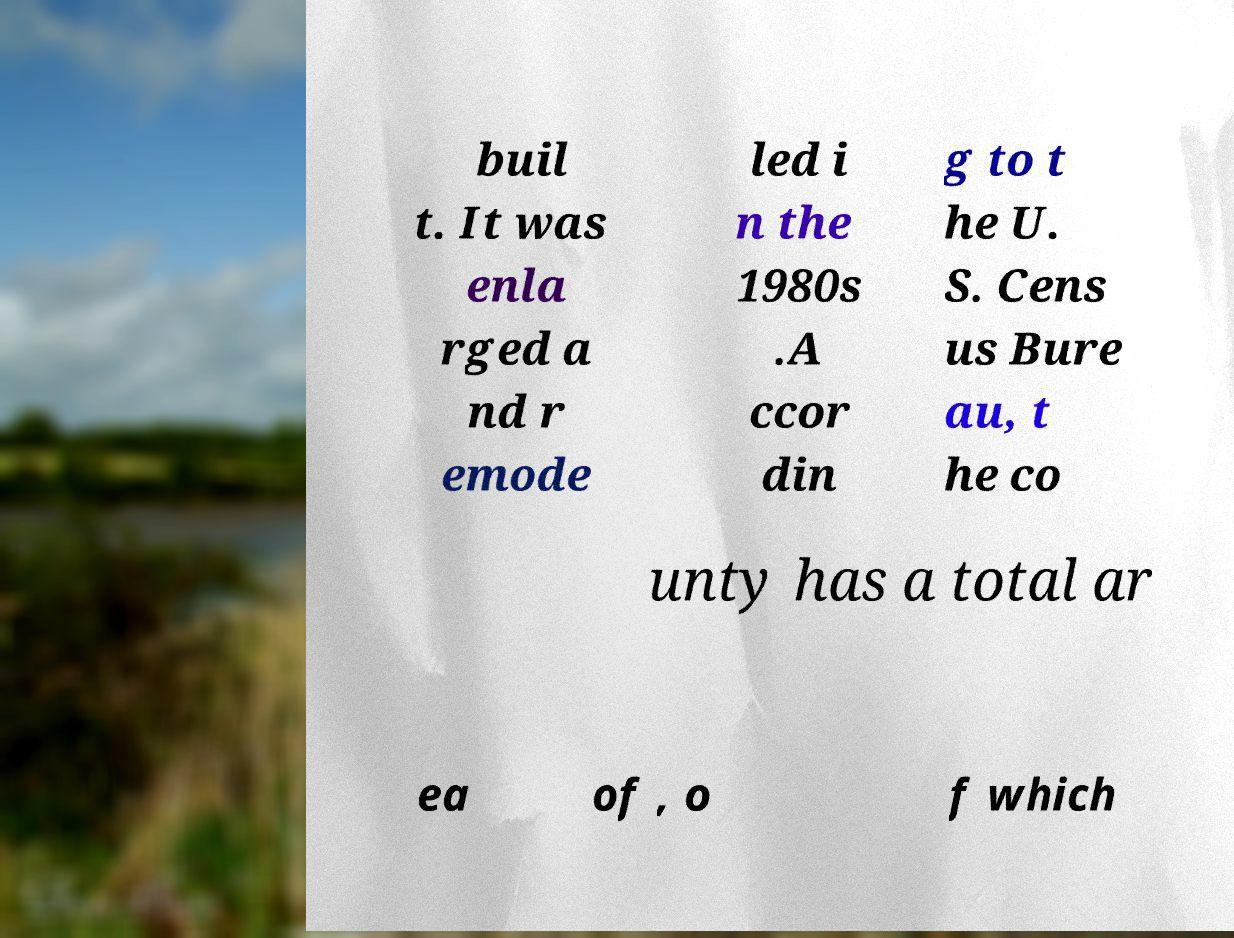Please identify and transcribe the text found in this image. buil t. It was enla rged a nd r emode led i n the 1980s .A ccor din g to t he U. S. Cens us Bure au, t he co unty has a total ar ea of , o f which 